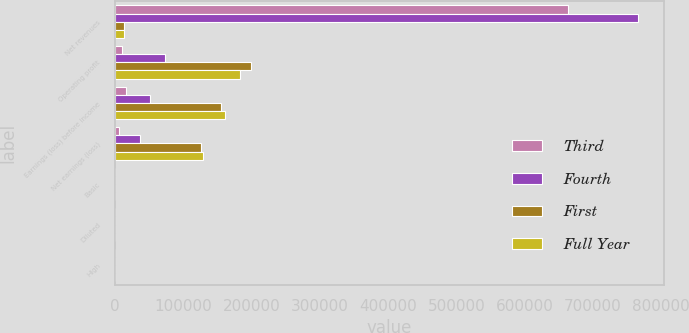Convert chart to OTSL. <chart><loc_0><loc_0><loc_500><loc_500><stacked_bar_chart><ecel><fcel>Net revenues<fcel>Operating profit<fcel>Earnings (loss) before income<fcel>Net earnings (loss)<fcel>Basic<fcel>Diluted<fcel>High<nl><fcel>Third<fcel>663694<fcel>10627<fcel>16493<fcel>6671<fcel>0.05<fcel>0.05<fcel>44.14<nl><fcel>Fourth<fcel>766342<fcel>74088<fcel>51076<fcel>36480<fcel>0.28<fcel>0.28<fcel>48.97<nl><fcel>First<fcel>13560<fcel>198706<fcel>155913<fcel>126574<fcel>0.97<fcel>0.96<fcel>49.75<nl><fcel>Full Year<fcel>13560<fcel>183672<fcel>161326<fcel>129815<fcel>0.99<fcel>0.98<fcel>54.55<nl></chart> 